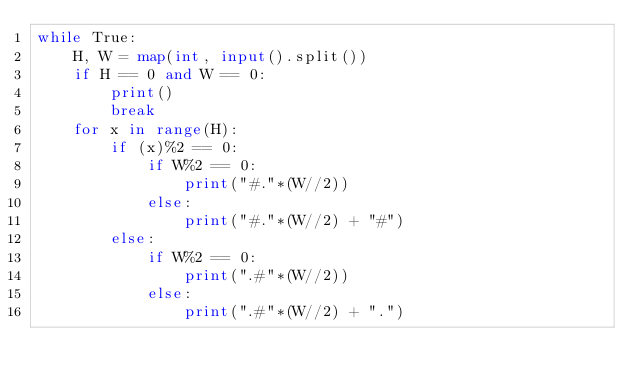<code> <loc_0><loc_0><loc_500><loc_500><_Python_>while True:
    H, W = map(int, input().split())
    if H == 0 and W == 0:
        print()
        break
    for x in range(H):
        if (x)%2 == 0:
            if W%2 == 0:
                print("#."*(W//2))
            else:
                print("#."*(W//2) + "#")
        else:
            if W%2 == 0:
                print(".#"*(W//2))
            else:
                print(".#"*(W//2) + ".")


</code> 